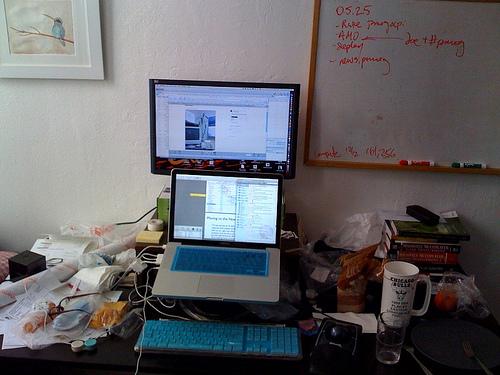Are they an organized family?
Quick response, please. No. What color are the markers?
Be succinct. Red and black. What word doesn't have a check mark beside it?
Write a very short answer. Compute. How many computers can be seen?
Keep it brief. 2. Is that a laptop in front of the computer?
Answer briefly. Yes. Is this a neatly organized workstation?
Keep it brief. No. 